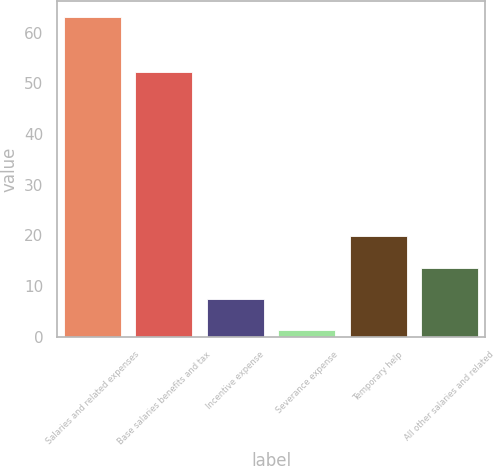<chart> <loc_0><loc_0><loc_500><loc_500><bar_chart><fcel>Salaries and related expenses<fcel>Base salaries benefits and tax<fcel>Incentive expense<fcel>Severance expense<fcel>Temporary help<fcel>All other salaries and related<nl><fcel>63.1<fcel>52.2<fcel>7.48<fcel>1.3<fcel>19.84<fcel>13.66<nl></chart> 